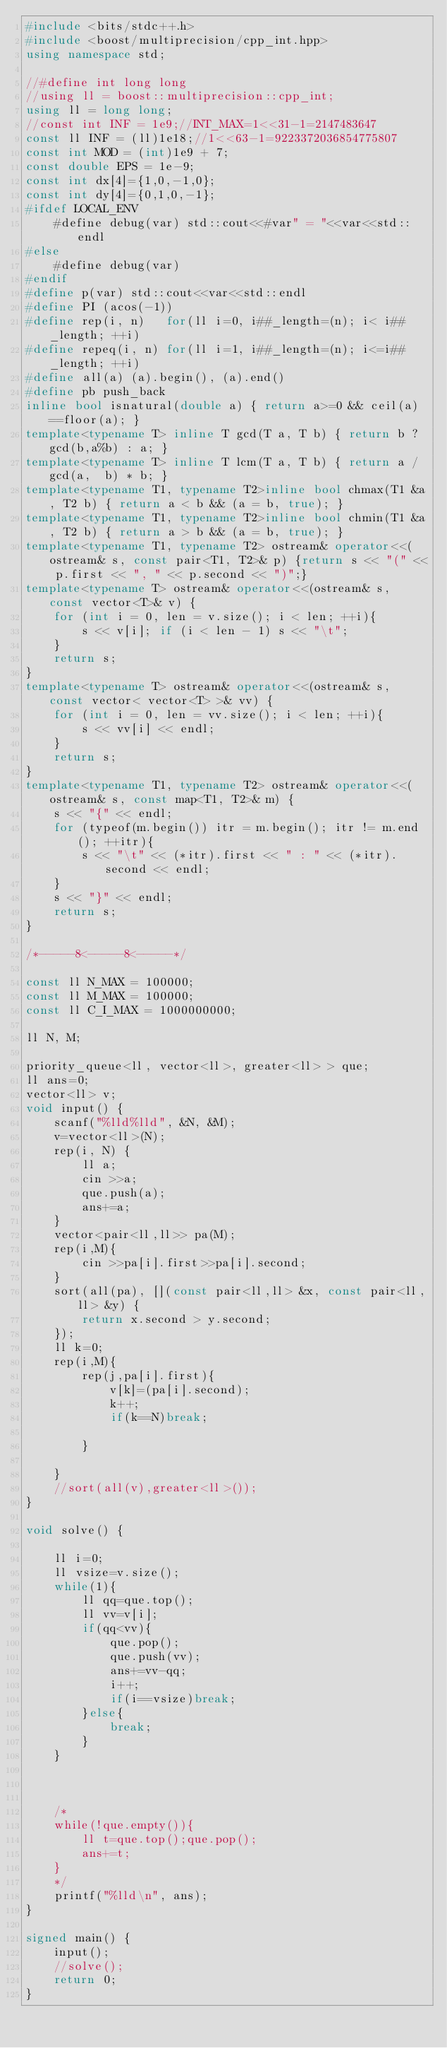<code> <loc_0><loc_0><loc_500><loc_500><_C++_>#include <bits/stdc++.h>
#include <boost/multiprecision/cpp_int.hpp>
using namespace std;

//#define int long long
//using ll = boost::multiprecision::cpp_int;
using ll = long long;
//const int INF = 1e9;//INT_MAX=1<<31-1=2147483647
const ll INF = (ll)1e18;//1<<63-1=9223372036854775807
const int MOD = (int)1e9 + 7;
const double EPS = 1e-9;
const int dx[4]={1,0,-1,0};
const int dy[4]={0,1,0,-1};
#ifdef LOCAL_ENV
	#define debug(var) std::cout<<#var" = "<<var<<std::endl
#else
	#define debug(var)
#endif
#define p(var) std::cout<<var<<std::endl
#define PI (acos(-1))
#define rep(i, n)   for(ll i=0, i##_length=(n); i< i##_length; ++i)
#define repeq(i, n) for(ll i=1, i##_length=(n); i<=i##_length; ++i)
#define all(a) (a).begin(), (a).end()
#define pb push_back
inline bool isnatural(double a) { return a>=0 && ceil(a)==floor(a); }
template<typename T> inline T gcd(T a, T b) { return b ? gcd(b,a%b) : a; }
template<typename T> inline T lcm(T a, T b) { return a / gcd(a,  b) * b; }
template<typename T1, typename T2>inline bool chmax(T1 &a, T2 b) { return a < b && (a = b, true); }
template<typename T1, typename T2>inline bool chmin(T1 &a, T2 b) { return a > b && (a = b, true); }
template<typename T1, typename T2> ostream& operator<<(ostream& s, const pair<T1, T2>& p) {return s << "(" << p.first << ", " << p.second << ")";}
template<typename T> ostream& operator<<(ostream& s, const vector<T>& v) {
	for (int i = 0, len = v.size(); i < len; ++i){
		s << v[i]; if (i < len - 1) s << "\t";
	}
	return s;
}
template<typename T> ostream& operator<<(ostream& s, const vector< vector<T> >& vv) {
	for (int i = 0, len = vv.size(); i < len; ++i){
		s << vv[i] << endl;
	}
	return s;
}
template<typename T1, typename T2> ostream& operator<<(ostream& s, const map<T1, T2>& m) {
	s << "{" << endl;
	for (typeof(m.begin()) itr = m.begin(); itr != m.end(); ++itr){
		s << "\t" << (*itr).first << " : " << (*itr).second << endl;
	}
	s << "}" << endl;
	return s;
}

/*-----8<-----8<-----*/

const ll N_MAX = 100000;
const ll M_MAX = 100000;
const ll C_I_MAX = 1000000000;

ll N, M;

priority_queue<ll, vector<ll>, greater<ll> > que;
ll ans=0;
vector<ll> v;
void input() {
	scanf("%lld%lld", &N, &M);
	v=vector<ll>(N);
	rep(i, N) {
		ll a;
		cin >>a;
		que.push(a);
		ans+=a;
	}
	vector<pair<ll,ll>> pa(M);
	rep(i,M){
		cin >>pa[i].first>>pa[i].second;
	}
	sort(all(pa), [](const pair<ll,ll> &x, const pair<ll,ll> &y) {
		return x.second > y.second;
	});
	ll k=0;
	rep(i,M){
		rep(j,pa[i].first){
			v[k]=(pa[i].second);
			k++;
			if(k==N)break;

		}

	}
	//sort(all(v),greater<ll>());
}

void solve() {

	ll i=0;
	ll vsize=v.size();
	while(1){
		ll qq=que.top();
		ll vv=v[i];
		if(qq<vv){
			que.pop();
			que.push(vv);
			ans+=vv-qq;
			i++;
			if(i==vsize)break;
		}else{
			break;
		}	
	}



	/*
	while(!que.empty()){
		ll t=que.top();que.pop();
		ans+=t;
	}
	*/
	printf("%lld\n", ans);
}

signed main() {
	input();
	//solve();
	return 0;
}
</code> 